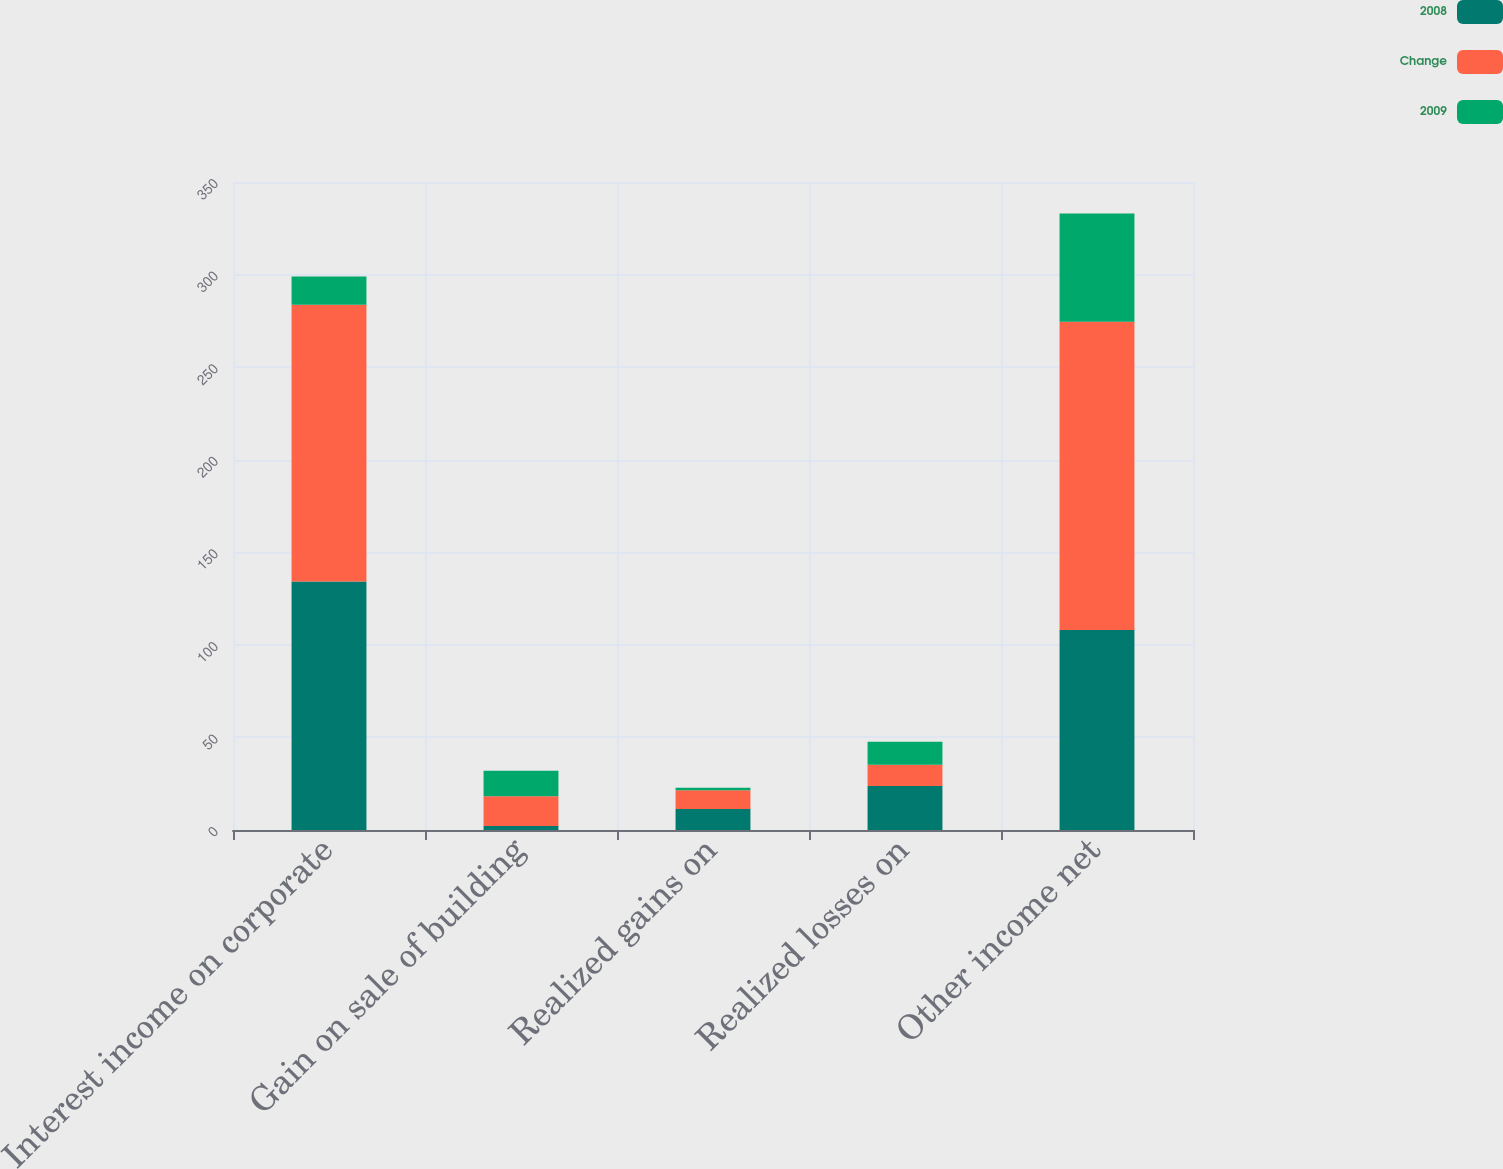<chart> <loc_0><loc_0><loc_500><loc_500><stacked_bar_chart><ecel><fcel>Interest income on corporate<fcel>Gain on sale of building<fcel>Realized gains on<fcel>Realized losses on<fcel>Other income net<nl><fcel>2008<fcel>134.2<fcel>2.2<fcel>11.4<fcel>23.8<fcel>108<nl><fcel>Change<fcel>149.5<fcel>16<fcel>10.1<fcel>11.4<fcel>166.5<nl><fcel>2009<fcel>15.3<fcel>13.8<fcel>1.3<fcel>12.4<fcel>58.5<nl></chart> 